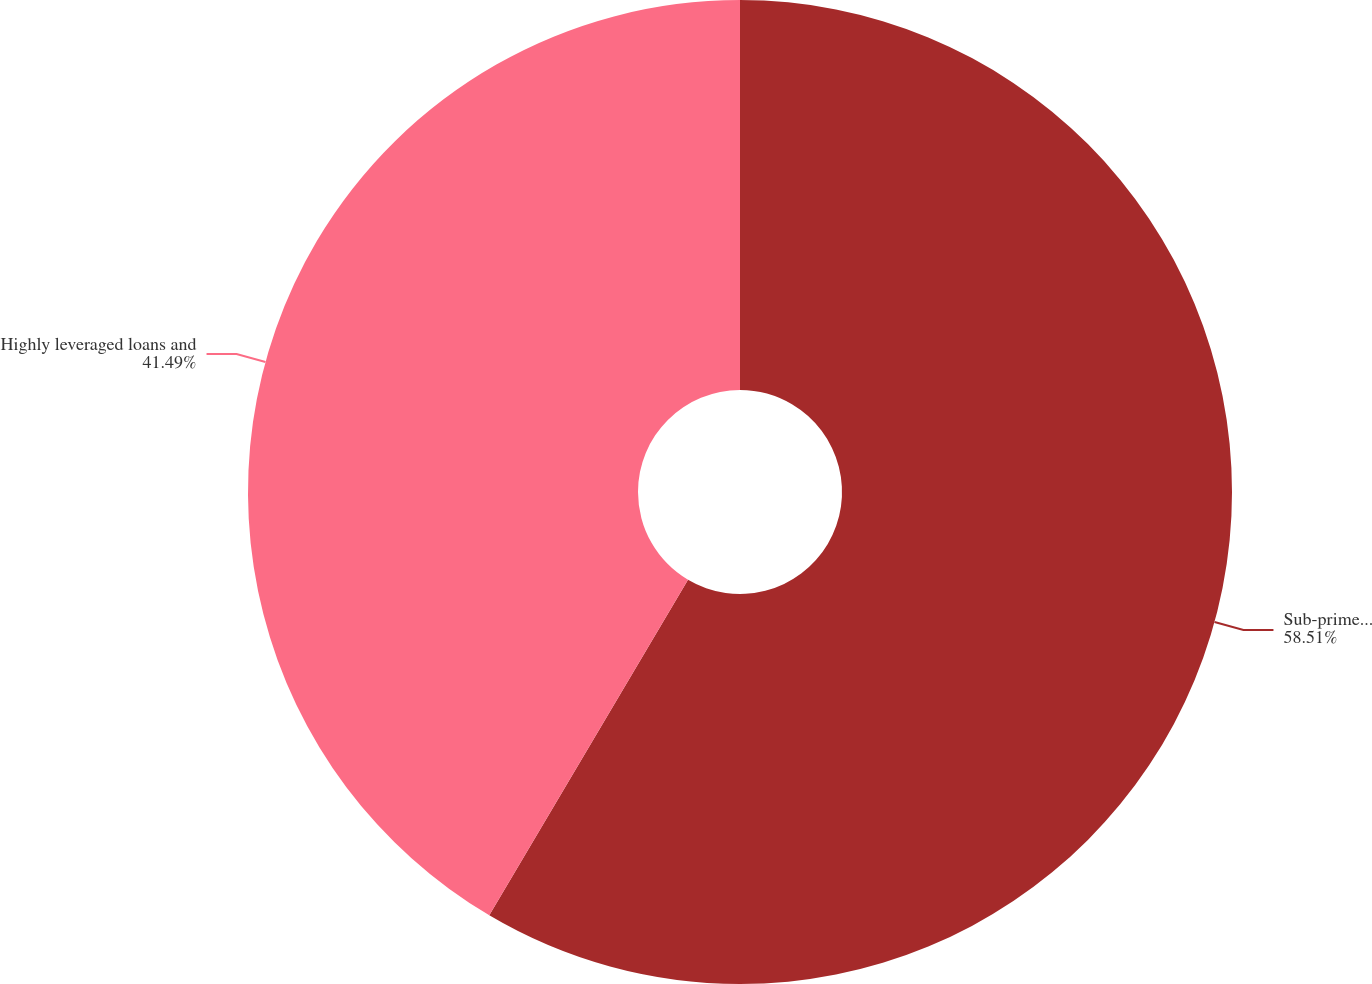Convert chart to OTSL. <chart><loc_0><loc_0><loc_500><loc_500><pie_chart><fcel>Sub-prime related direct<fcel>Highly leveraged loans and<nl><fcel>58.51%<fcel>41.49%<nl></chart> 